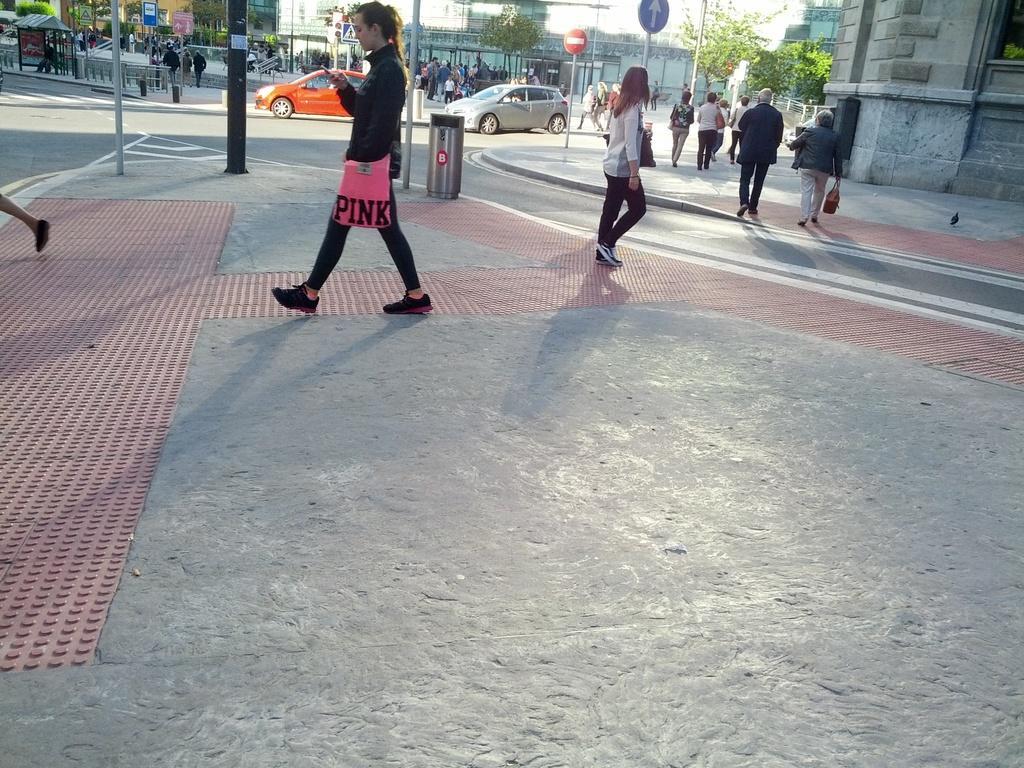Could you give a brief overview of what you see in this image? In this picture I can see few buildings and trees and I can see few people walking and few are standing and I can see couple of cars moving on the road and few sign boards on the side walk and I can see a dustbin and a bird on the sidewalk. 